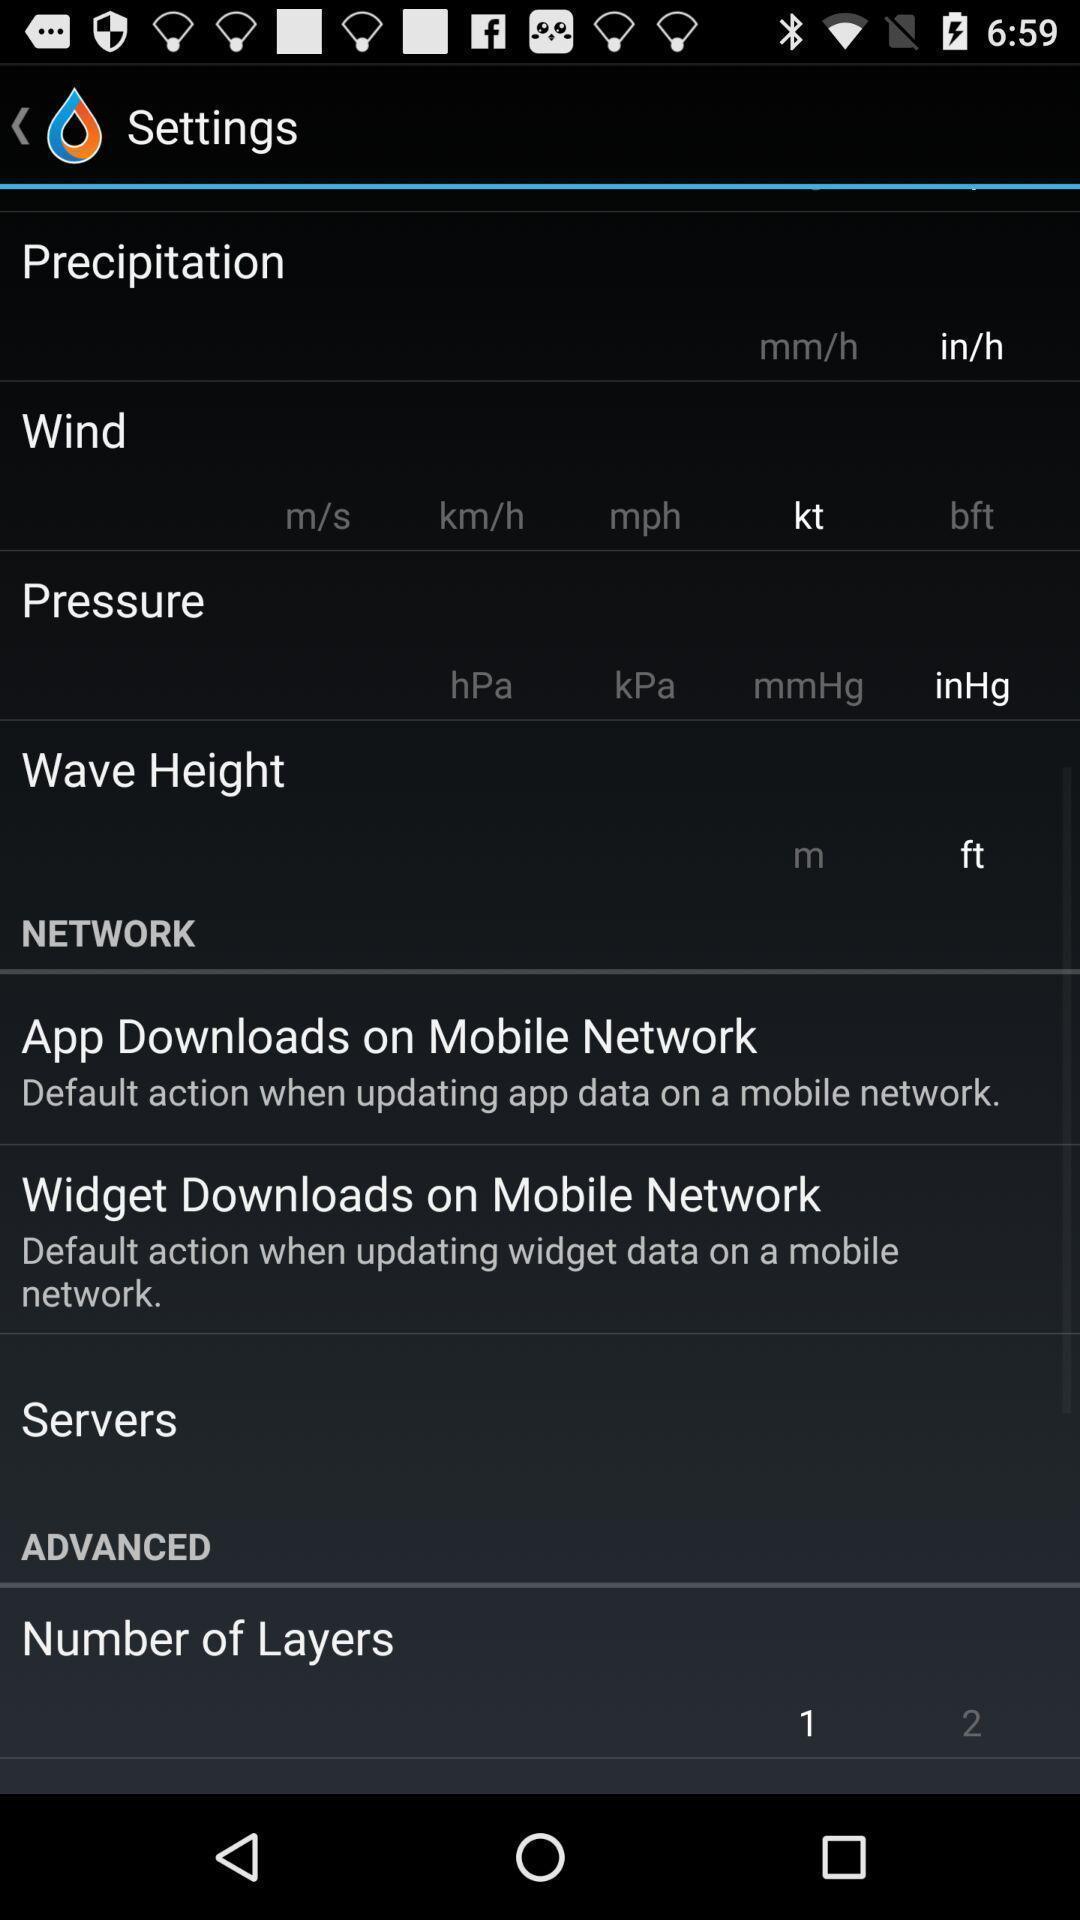Provide a description of this screenshot. Setting page displaying various options. 